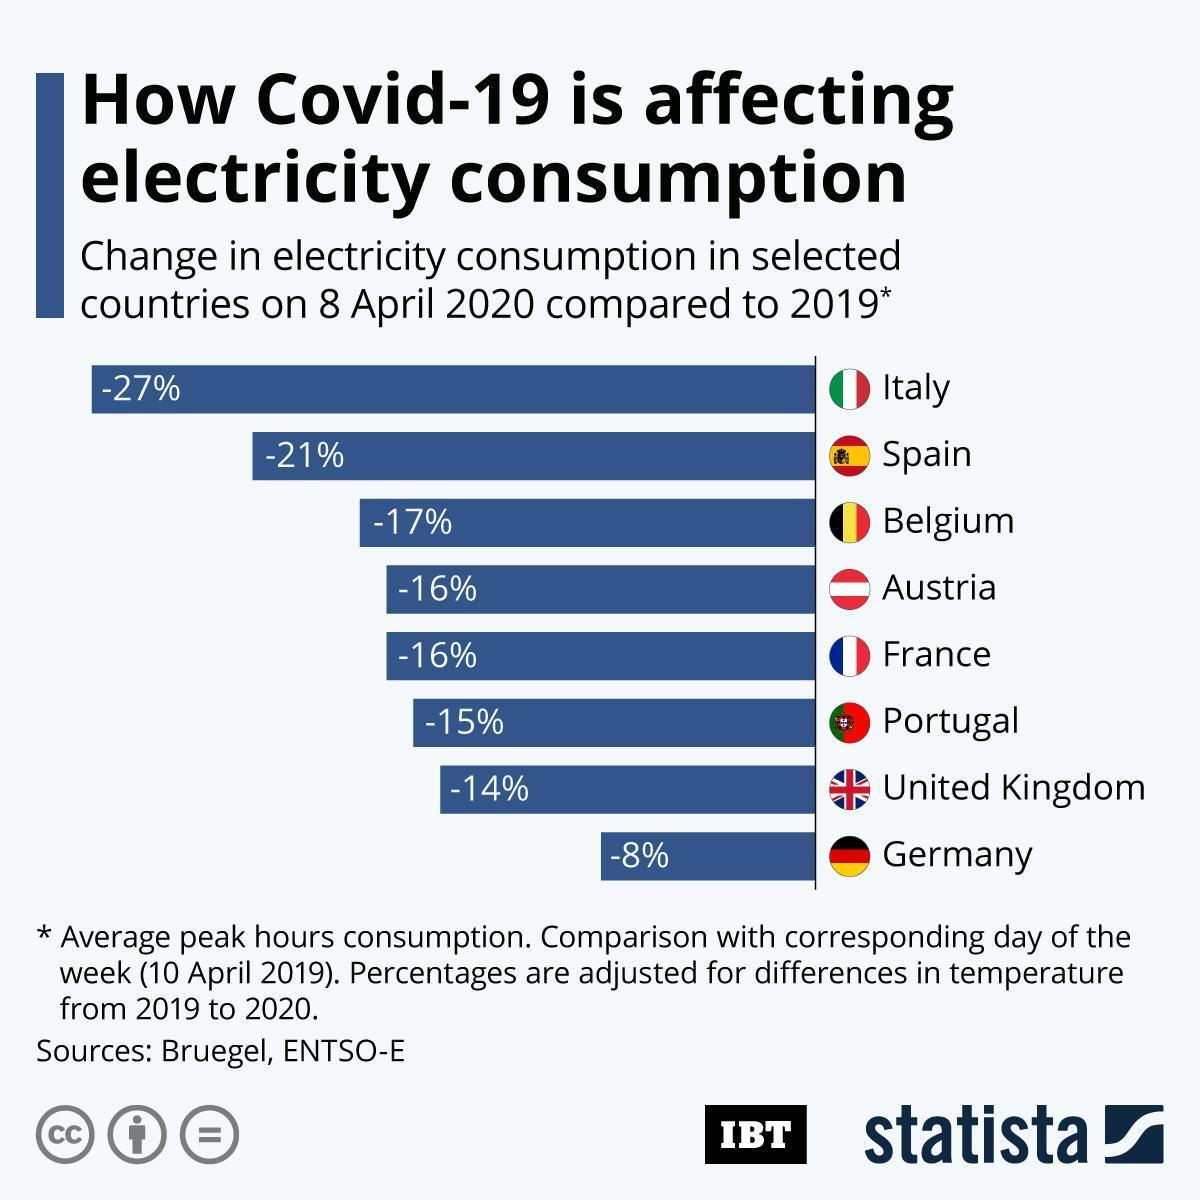Which country has shown the least percentage change in electricity consumption among the selected countries on 8 April 2020 compared to 2019?
Answer the question with a short phrase. Germany Which country has shown the second highest percentage change in electricity consumption among the selected countries on 8 April 2020 compared to 2019? Spain What is the percentage change in the electricity consumption of the UK on 8 April 2020 compared to 2019? -14% What is the percentage change in the electricity consumption of Spain on 8 April 2020 compared to 2019? -21% Which country has shown the highest percentage change in electricity consumption among the selected countries on 8 April 2020 compared to 2019? Italy 